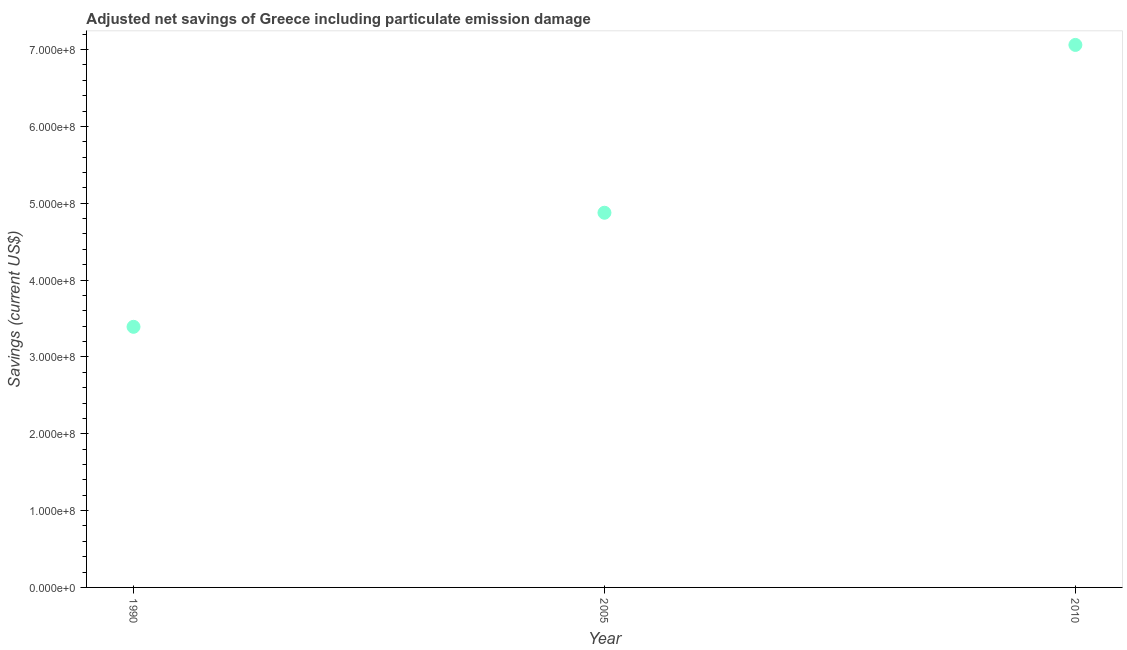What is the adjusted net savings in 2005?
Give a very brief answer. 4.88e+08. Across all years, what is the maximum adjusted net savings?
Provide a succinct answer. 7.06e+08. Across all years, what is the minimum adjusted net savings?
Give a very brief answer. 3.39e+08. In which year was the adjusted net savings maximum?
Make the answer very short. 2010. In which year was the adjusted net savings minimum?
Your answer should be compact. 1990. What is the sum of the adjusted net savings?
Offer a very short reply. 1.53e+09. What is the difference between the adjusted net savings in 1990 and 2005?
Provide a succinct answer. -1.48e+08. What is the average adjusted net savings per year?
Your response must be concise. 5.11e+08. What is the median adjusted net savings?
Provide a short and direct response. 4.88e+08. In how many years, is the adjusted net savings greater than 320000000 US$?
Your answer should be compact. 3. Do a majority of the years between 2005 and 2010 (inclusive) have adjusted net savings greater than 520000000 US$?
Keep it short and to the point. No. What is the ratio of the adjusted net savings in 1990 to that in 2005?
Give a very brief answer. 0.7. Is the adjusted net savings in 2005 less than that in 2010?
Offer a very short reply. Yes. What is the difference between the highest and the second highest adjusted net savings?
Your answer should be compact. 2.18e+08. What is the difference between the highest and the lowest adjusted net savings?
Your response must be concise. 3.67e+08. In how many years, is the adjusted net savings greater than the average adjusted net savings taken over all years?
Provide a succinct answer. 1. Does the adjusted net savings monotonically increase over the years?
Offer a terse response. Yes. How many dotlines are there?
Offer a terse response. 1. How many years are there in the graph?
Offer a very short reply. 3. Are the values on the major ticks of Y-axis written in scientific E-notation?
Make the answer very short. Yes. What is the title of the graph?
Offer a terse response. Adjusted net savings of Greece including particulate emission damage. What is the label or title of the Y-axis?
Your answer should be compact. Savings (current US$). What is the Savings (current US$) in 1990?
Provide a succinct answer. 3.39e+08. What is the Savings (current US$) in 2005?
Make the answer very short. 4.88e+08. What is the Savings (current US$) in 2010?
Your answer should be compact. 7.06e+08. What is the difference between the Savings (current US$) in 1990 and 2005?
Provide a succinct answer. -1.48e+08. What is the difference between the Savings (current US$) in 1990 and 2010?
Your answer should be very brief. -3.67e+08. What is the difference between the Savings (current US$) in 2005 and 2010?
Your answer should be very brief. -2.18e+08. What is the ratio of the Savings (current US$) in 1990 to that in 2005?
Offer a terse response. 0.7. What is the ratio of the Savings (current US$) in 1990 to that in 2010?
Provide a succinct answer. 0.48. What is the ratio of the Savings (current US$) in 2005 to that in 2010?
Your answer should be very brief. 0.69. 